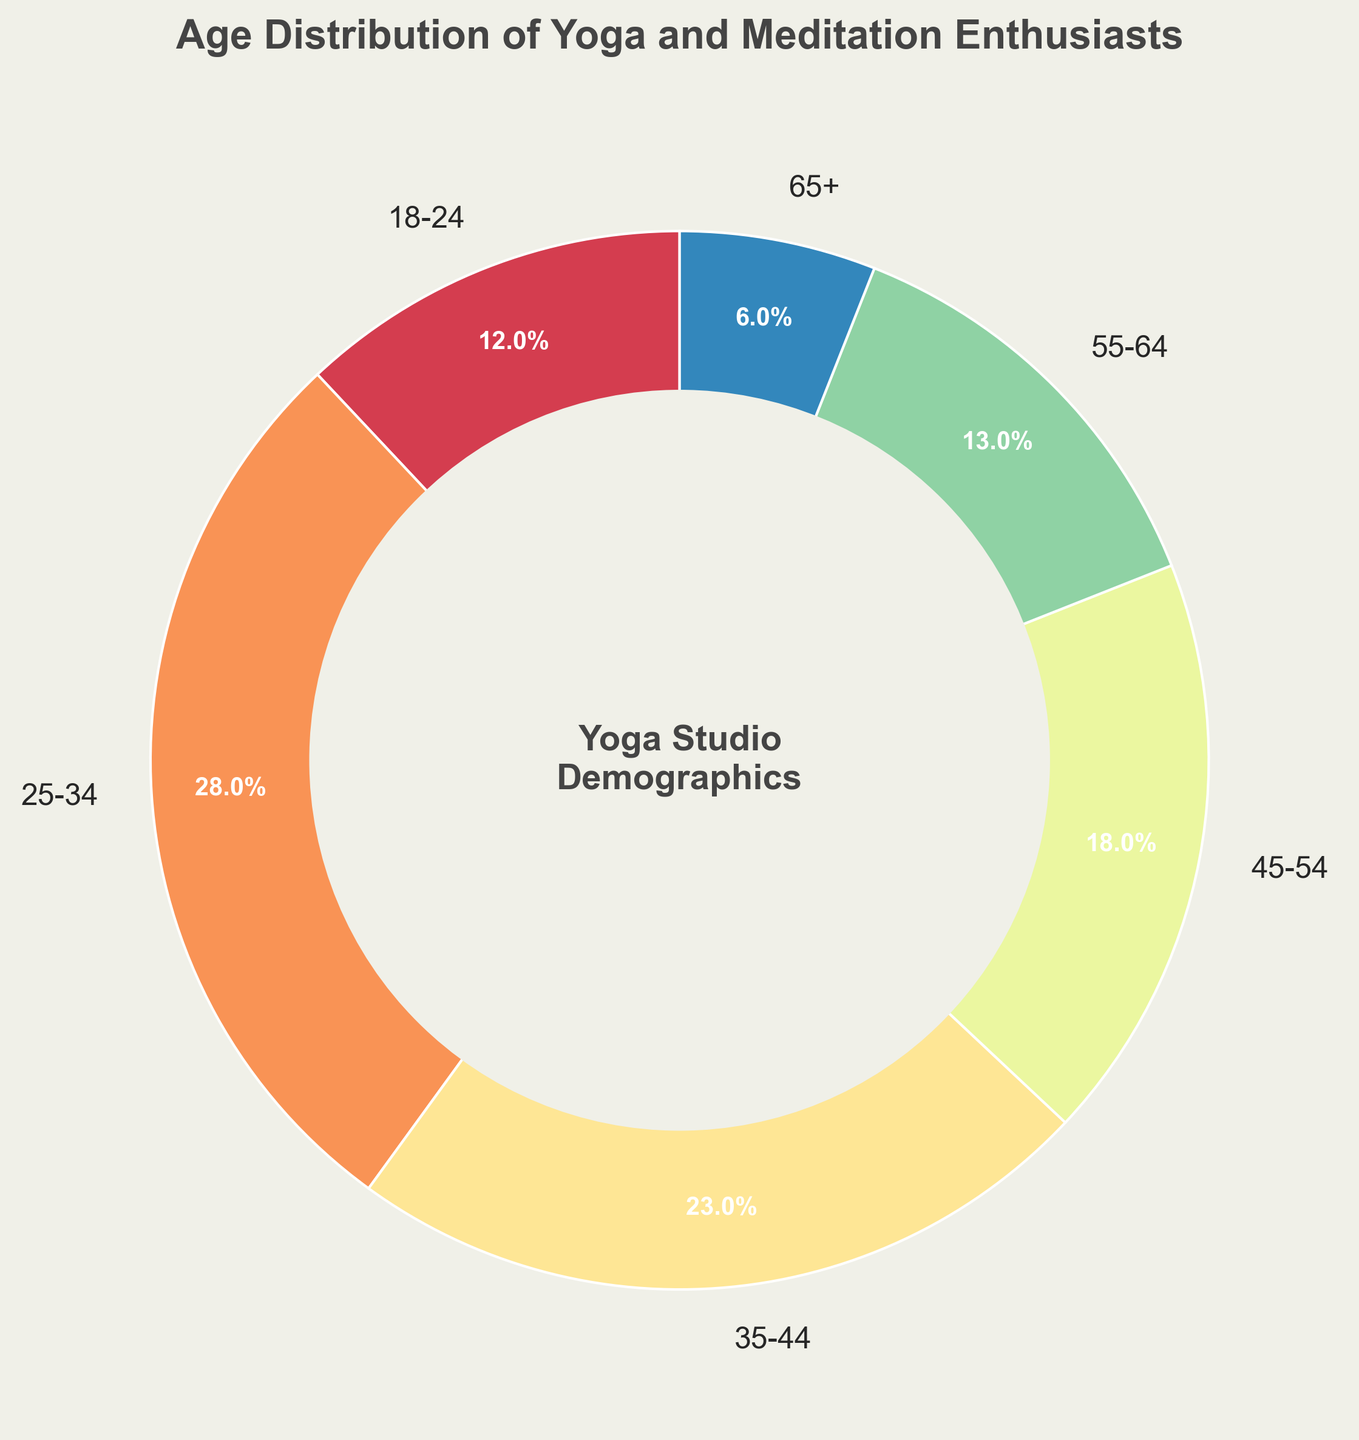Which age group has the largest percentage of yoga and meditation enthusiasts? To find the age group with the largest percentage, look at the labels and the corresponding percentages. The age group 25-34 has the highest value at 28%.
Answer: 25-34 Which age group has the smallest percentage of yoga and meditation enthusiasts? To find the age group with the smallest percentage, look at the labels and the corresponding percentages. The age group 65+ has the lowest value at 6%.
Answer: 65+ What is the total percentage of yoga and meditation enthusiasts aged 45 and above? To find the total percentage for those aged 45 and above, add up the percentages of the age groups: 45-54 (18%), 55-64 (13%), and 65+ (6%). The total is 18 + 13 + 6 = 37%.
Answer: 37% How much larger is the percentage of the 25-34 age group compared to the 18-24 age group? To find how much larger the 25-34 age group is, subtract the percentage of the 18-24 group from the 25-34 group: 28% - 12% = 16%.
Answer: 16% What is the combined percentage for the age groups 18-24 and 35-44? To find the combined percentage, add the values for the 18-24 (12%) and 35-44 (23%) age groups: 12% + 23% = 35%.
Answer: 35% Which two age groups have very similar percentages? To find similar percentages, compare the values of each pair of age groups. The 18-24 (12%) and 55-64 (13%) age groups have the closest percentages.
Answer: 18-24 and 55-64 What percentage of the yoga and meditation enthusiasts are younger than 35? To find the total percentage for those younger than 35, add up the percentages of the age groups: 18-24 (12%) and 25-34 (28%). The total is 12 + 28 = 40%.
Answer: 40% How do the percentages of the 35-44 and 45-54 age groups compare? To compare the percentages, note that the 35-44 age group is 23% and the 45-54 age group is 18%. The 35-44 age group is 5% higher than the 45-54 group.
Answer: 35-44 is 5% higher 